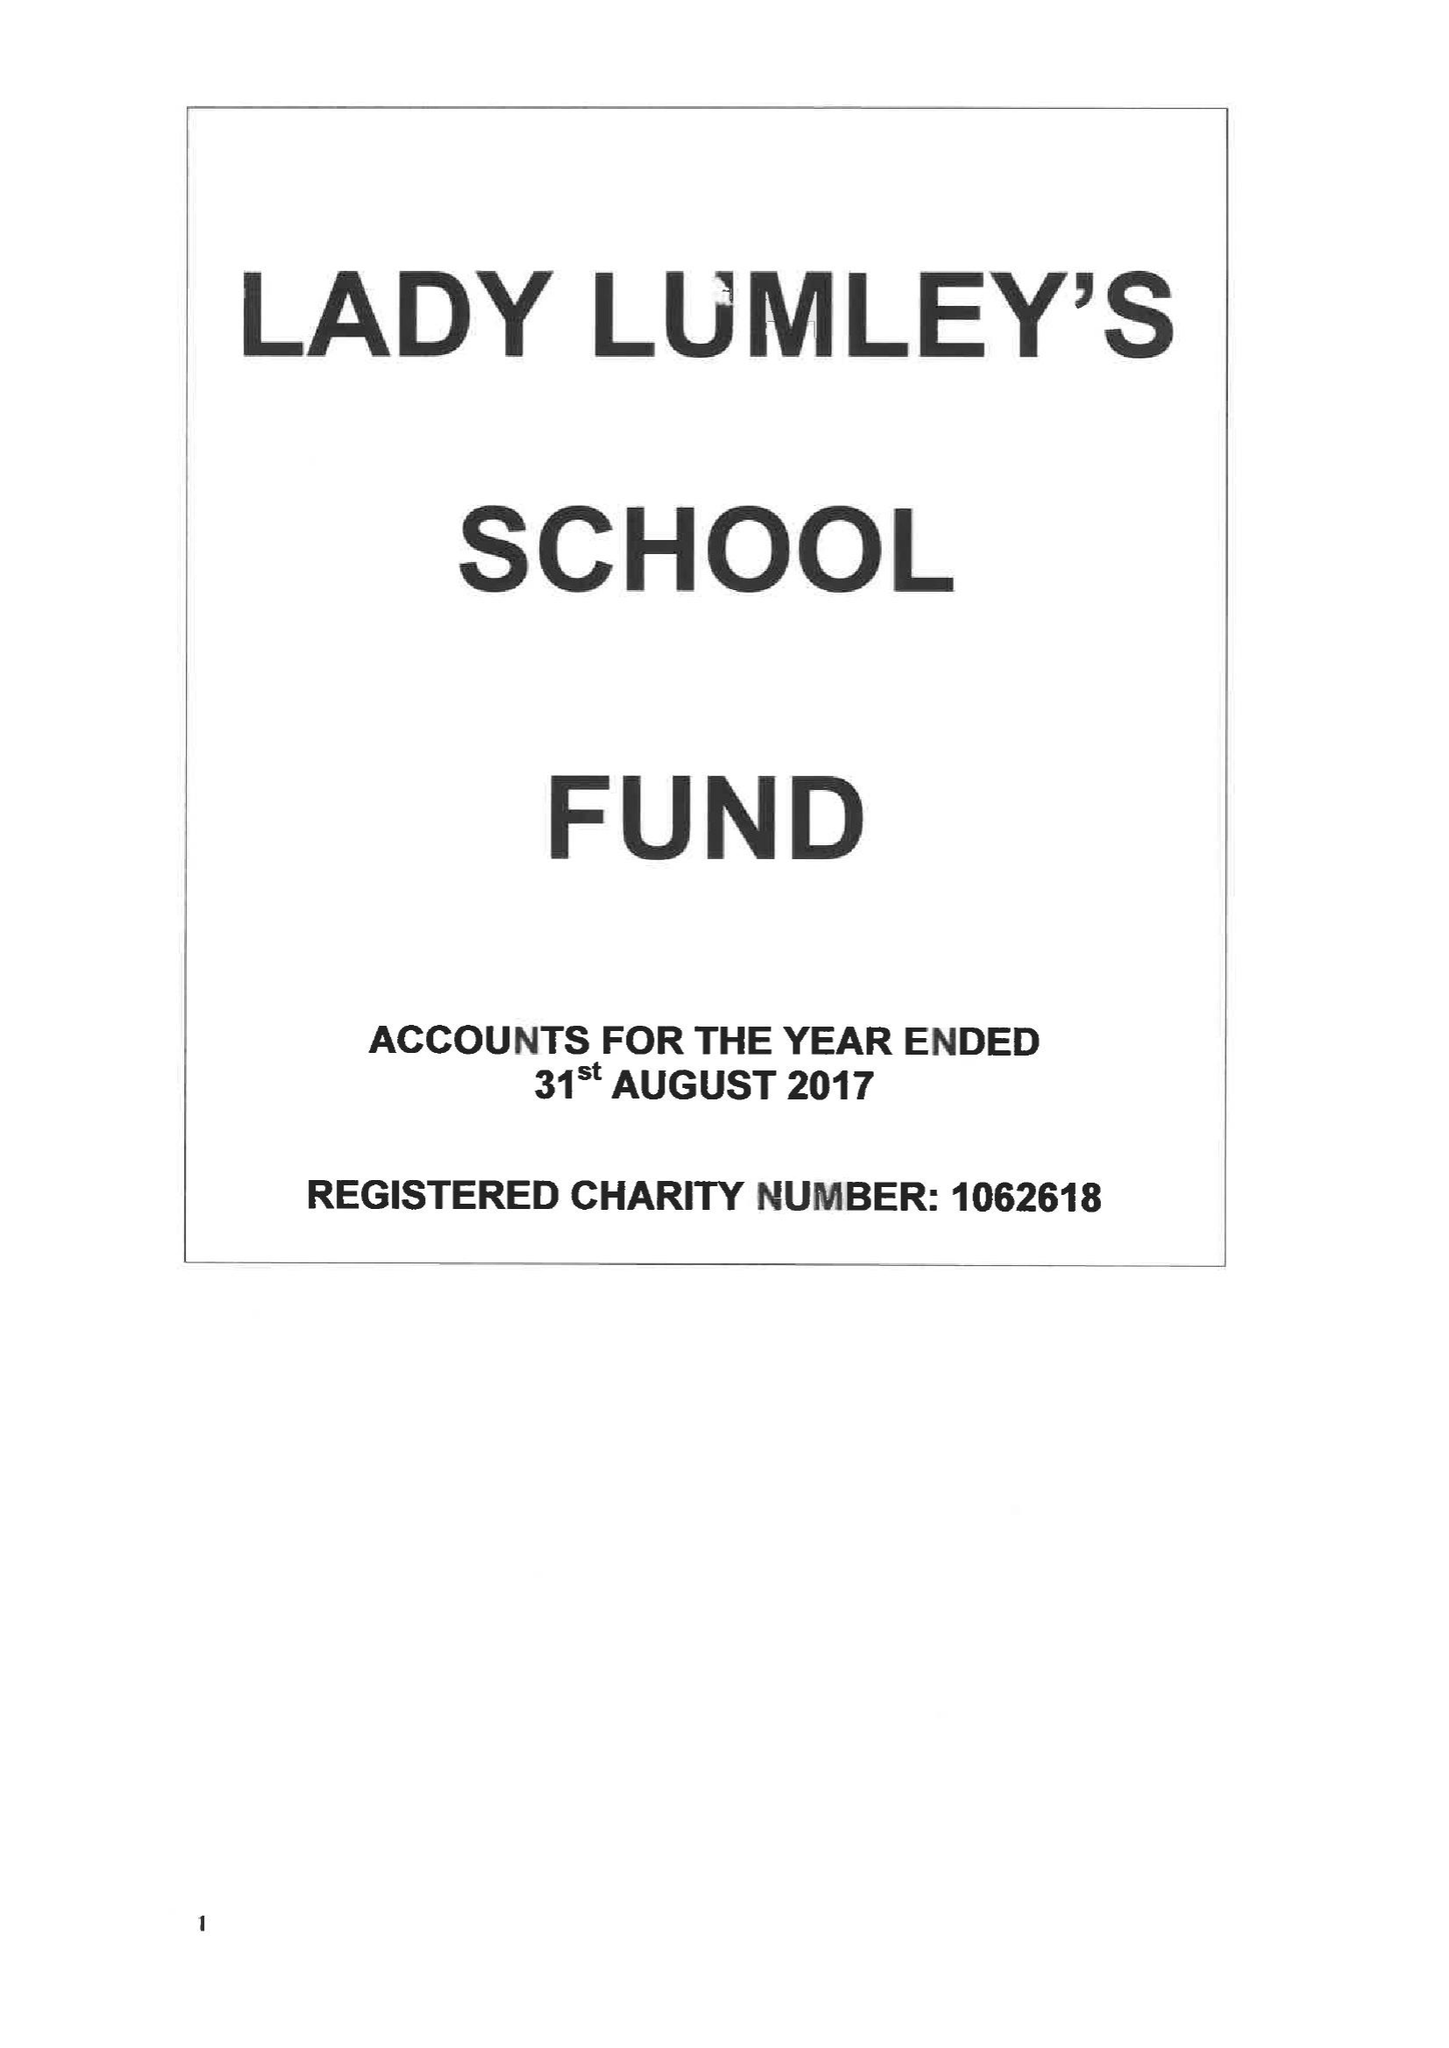What is the value for the charity_number?
Answer the question using a single word or phrase. 1062618 